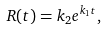Convert formula to latex. <formula><loc_0><loc_0><loc_500><loc_500>R ( t ) = k _ { 2 } e ^ { k _ { 1 } t } ,</formula> 